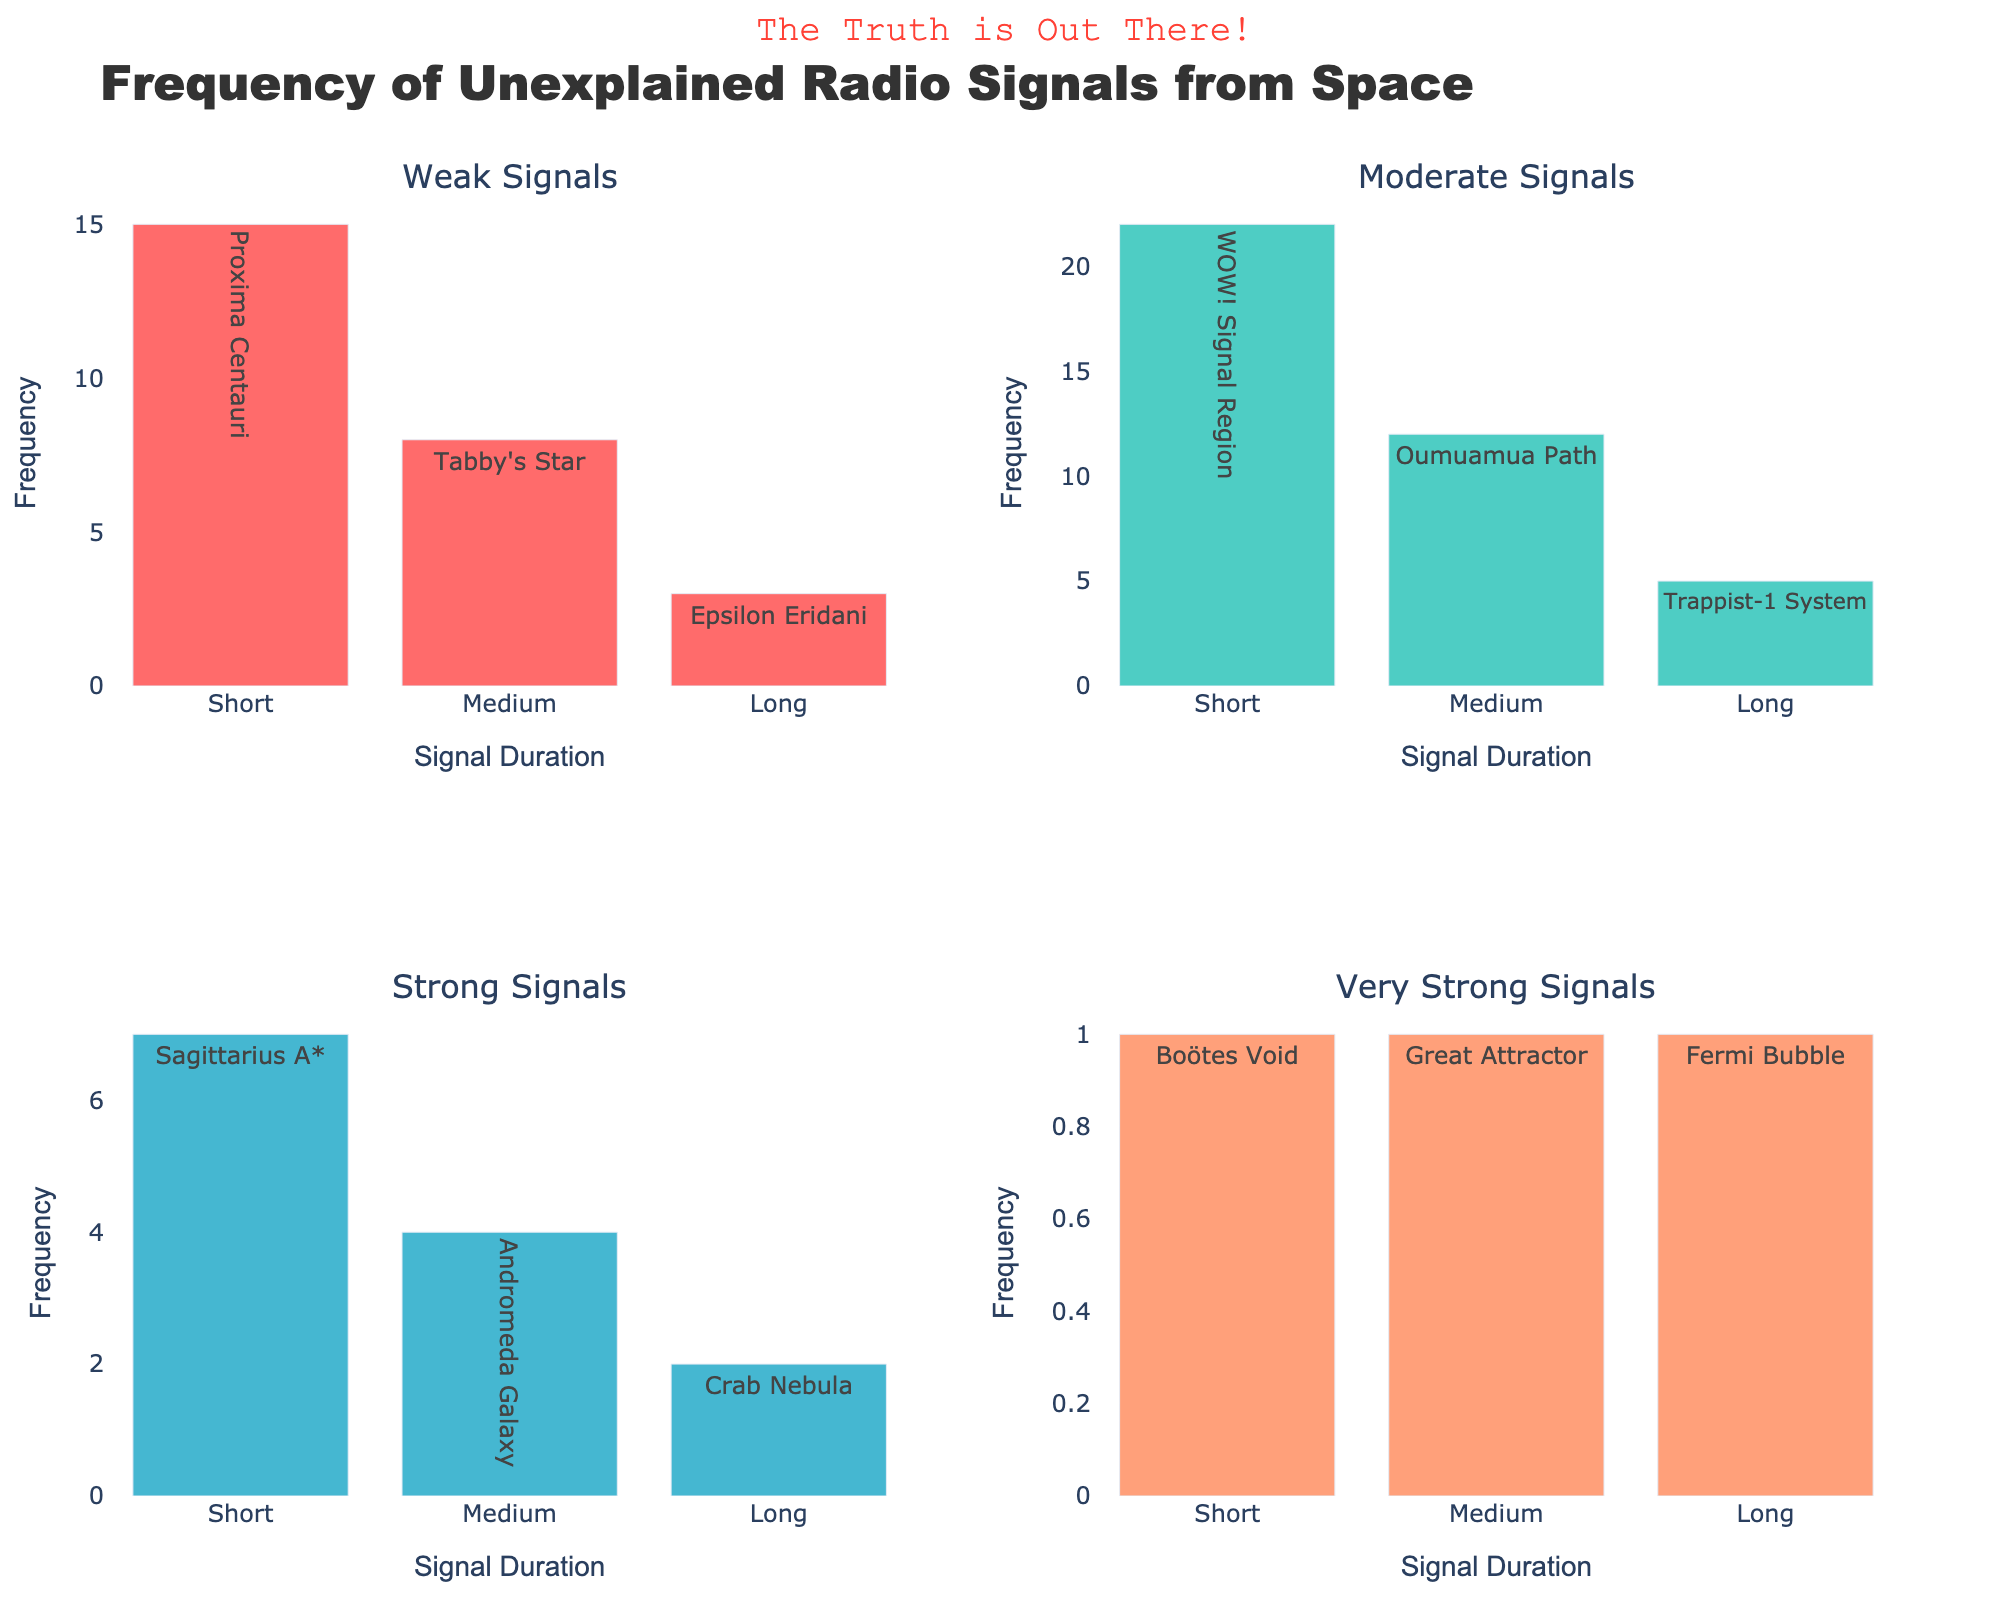Which category of signals has the highest total frequency across all duration types? To find the category with the highest total frequency, sum the frequencies across all durations for each signal strength: 
- Weak: 15 (Short) + 8 (Medium) + 3 (Long) = 26
- Moderate: 22 (Short) + 12 (Medium) + 5 (Long) = 39
- Strong: 7 (Short) + 4 (Medium) + 2 (Long) = 13
- Very Strong: 1 (Short) + 1 (Medium) + 1 (Long) = 3
Moderate signals have the highest total frequency, 39.
Answer: Moderate For the Moderate signal category, which duration type has the highest frequency? By observing the Moderate signals subplot, the bars represent frequency: 
- Short: 22
- Medium: 12
- Long: 5
The Short duration type has the highest frequency among Moderate signals.
Answer: Short How does the frequency of Weak signals with Short duration compare to Strong signals with Medium duration? To compare these frequencies, look at the corresponding bars in their subplots: 
- Weak signals with Short duration: 15
- Strong signals with Medium duration: 4
15 (Weak, Short) is greater than 4 (Strong, Medium).
Answer: The frequency is higher Which duration type has the most consistent frequency across all signal strengths? To assess consistency, observe which duration has the least variance in frequencies: 
- Short: 15 (Weak), 22 (Moderate), 7 (Strong), 1 (Very Strong)
- Medium: 8 (Weak), 12 (Moderate), 4 (Strong), 1 (Very Strong)
- Long: 3 (Weak), 5 (Moderate), 2 (Strong), 1 (Very Strong)
The Long duration seems the most consistent with minimal variation from 1 to 5 frequencies.
Answer: Long What is the total number of signals of all strengths and durations combined? Sum the frequencies of signals across all categories and durations:
- Weak: 15 (Short) + 8 (Medium) + 3 (Long) = 26
- Moderate: 22 (Short) + 12 (Medium) + 5 (Long) = 39
- Strong: 7 (Short) + 4 (Medium) + 2 (Long) = 13
- Very Strong: 1 (Short) + 1 (Medium) + 1 (Long) = 3
Total = 26 + 39 + 13 + 3 = 81
Answer: 81 